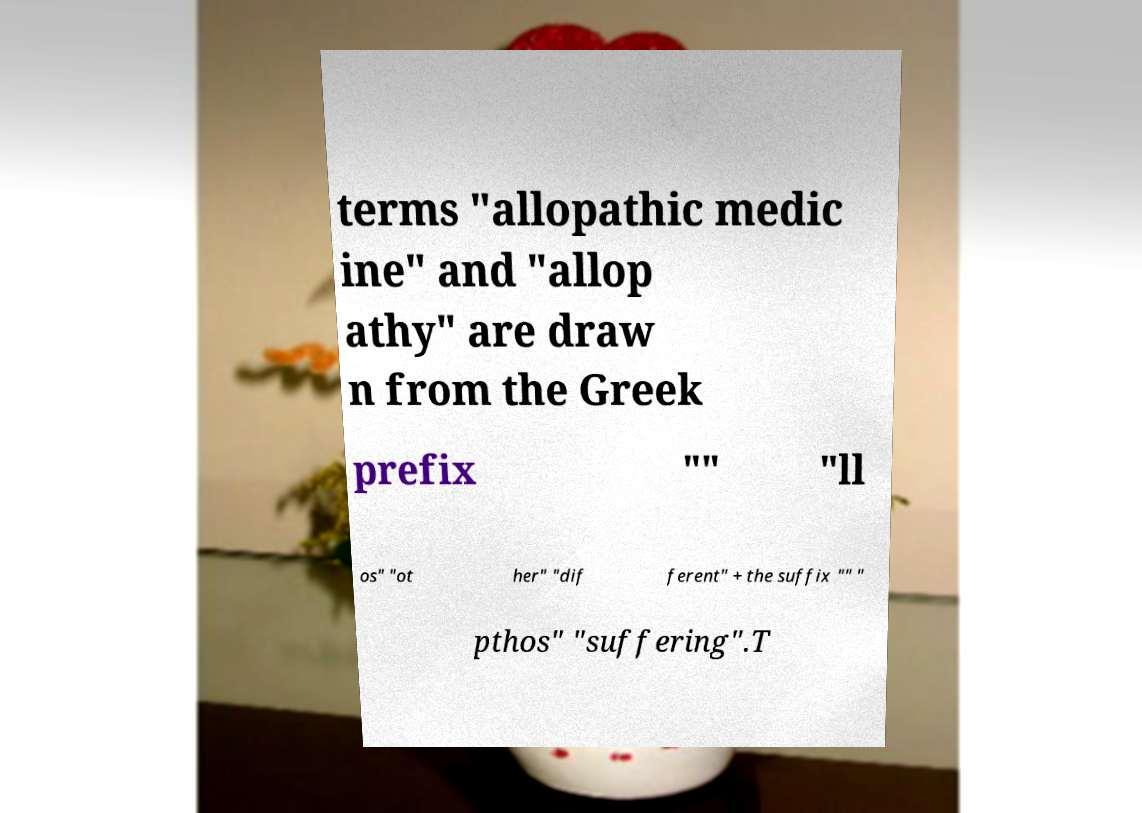Could you extract and type out the text from this image? terms "allopathic medic ine" and "allop athy" are draw n from the Greek prefix "" "ll os" "ot her" "dif ferent" + the suffix "" " pthos" "suffering".T 